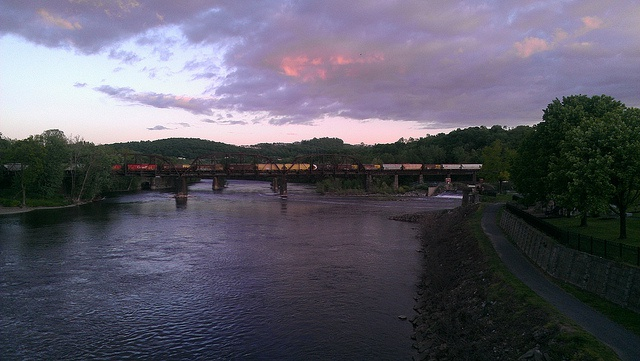Describe the objects in this image and their specific colors. I can see a train in gray, black, and maroon tones in this image. 